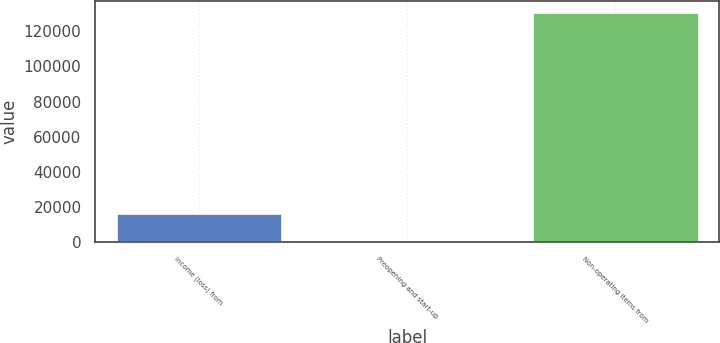<chart> <loc_0><loc_0><loc_500><loc_500><bar_chart><fcel>Income (loss) from<fcel>Preopening and start-up<fcel>Non-operating items from<nl><fcel>16800<fcel>656<fcel>130845<nl></chart> 